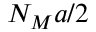Convert formula to latex. <formula><loc_0><loc_0><loc_500><loc_500>N _ { M } a / 2</formula> 